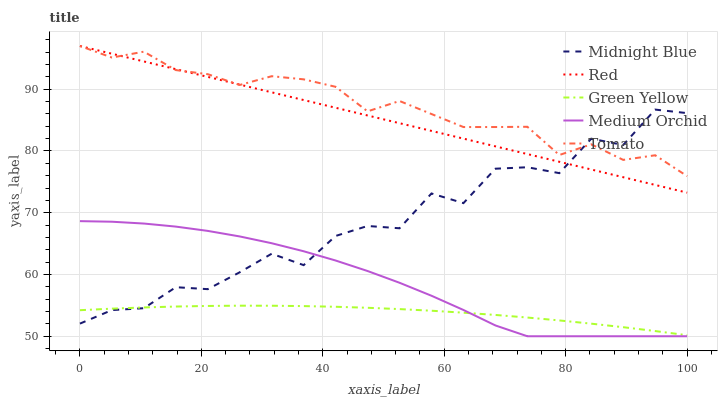Does Medium Orchid have the minimum area under the curve?
Answer yes or no. No. Does Medium Orchid have the maximum area under the curve?
Answer yes or no. No. Is Medium Orchid the smoothest?
Answer yes or no. No. Is Medium Orchid the roughest?
Answer yes or no. No. Does Green Yellow have the lowest value?
Answer yes or no. No. Does Medium Orchid have the highest value?
Answer yes or no. No. Is Medium Orchid less than Red?
Answer yes or no. Yes. Is Red greater than Green Yellow?
Answer yes or no. Yes. Does Medium Orchid intersect Red?
Answer yes or no. No. 